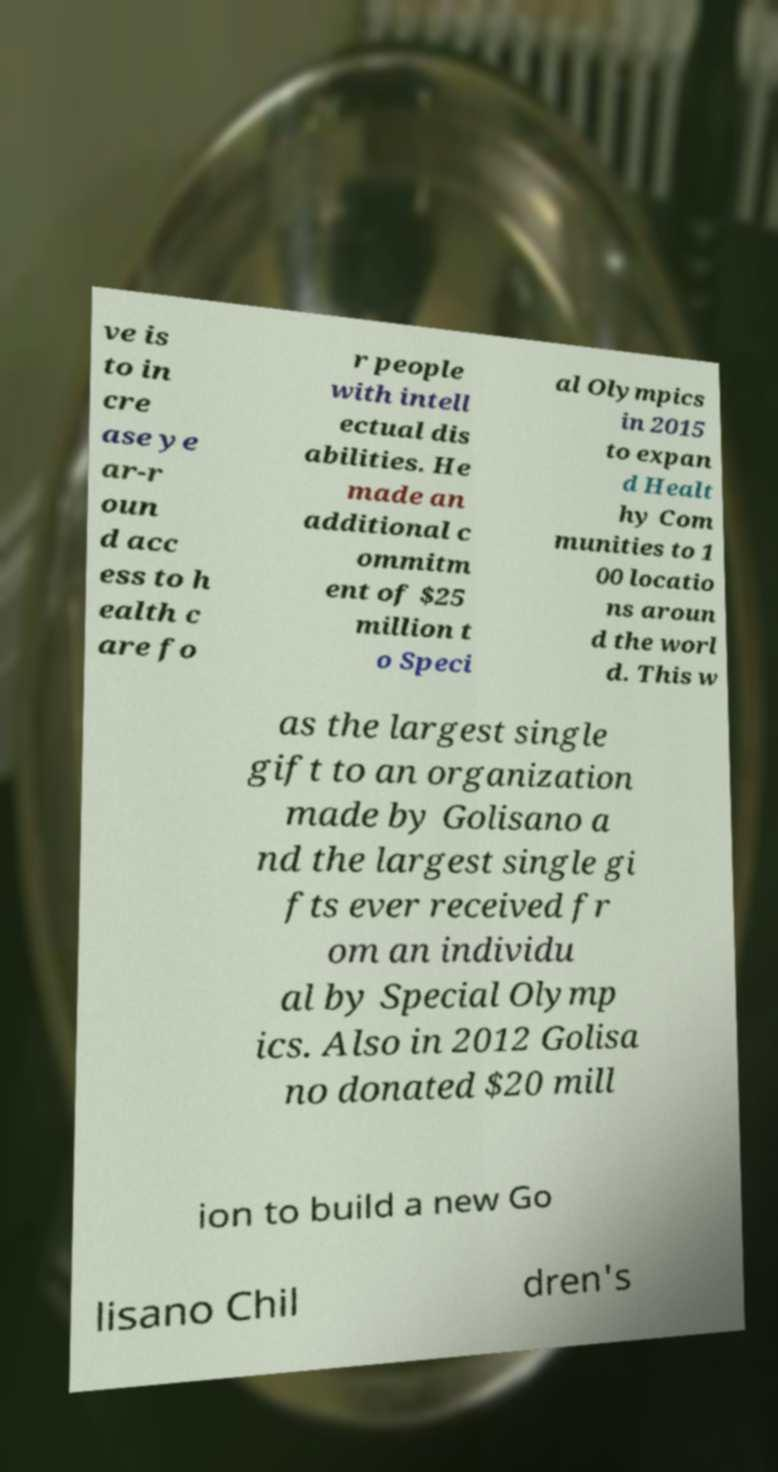Can you read and provide the text displayed in the image?This photo seems to have some interesting text. Can you extract and type it out for me? ve is to in cre ase ye ar-r oun d acc ess to h ealth c are fo r people with intell ectual dis abilities. He made an additional c ommitm ent of $25 million t o Speci al Olympics in 2015 to expan d Healt hy Com munities to 1 00 locatio ns aroun d the worl d. This w as the largest single gift to an organization made by Golisano a nd the largest single gi fts ever received fr om an individu al by Special Olymp ics. Also in 2012 Golisa no donated $20 mill ion to build a new Go lisano Chil dren's 